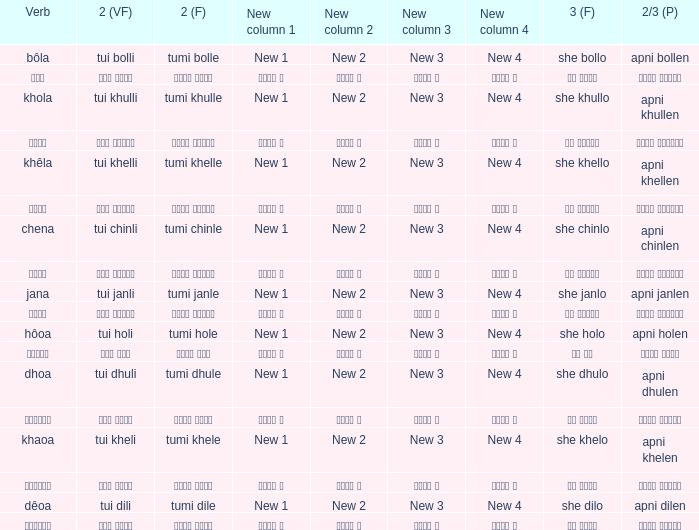What is the second verb associated with chena? Tumi chinle. 